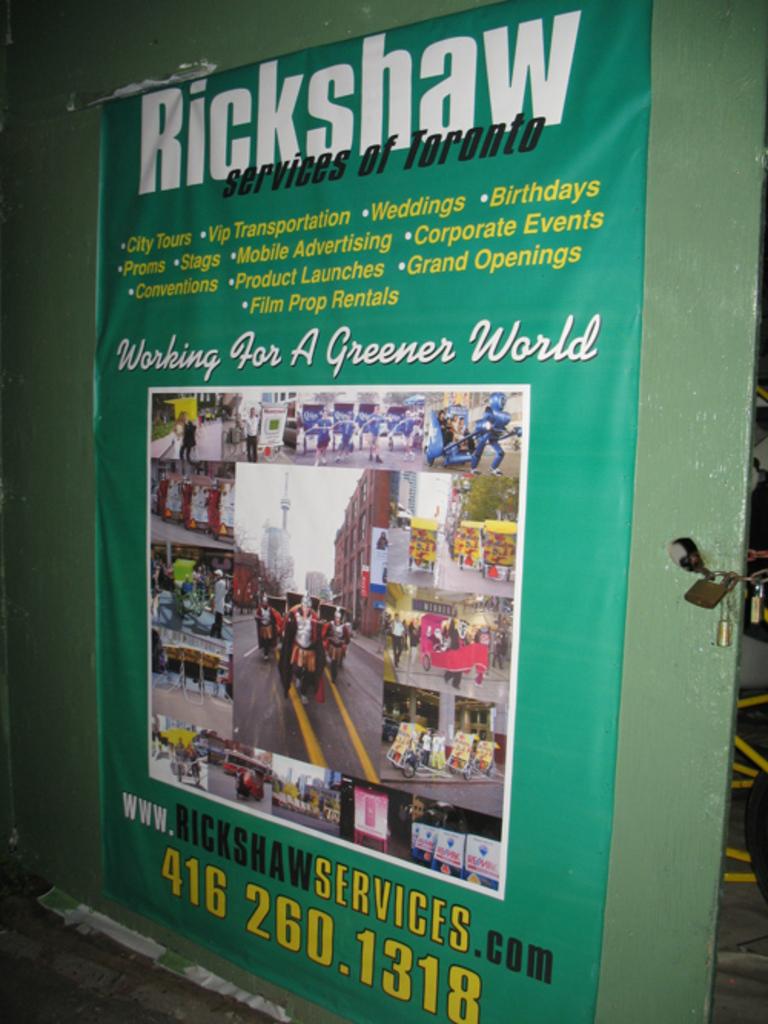What is the company name?
Ensure brevity in your answer.  Rickshaw. 